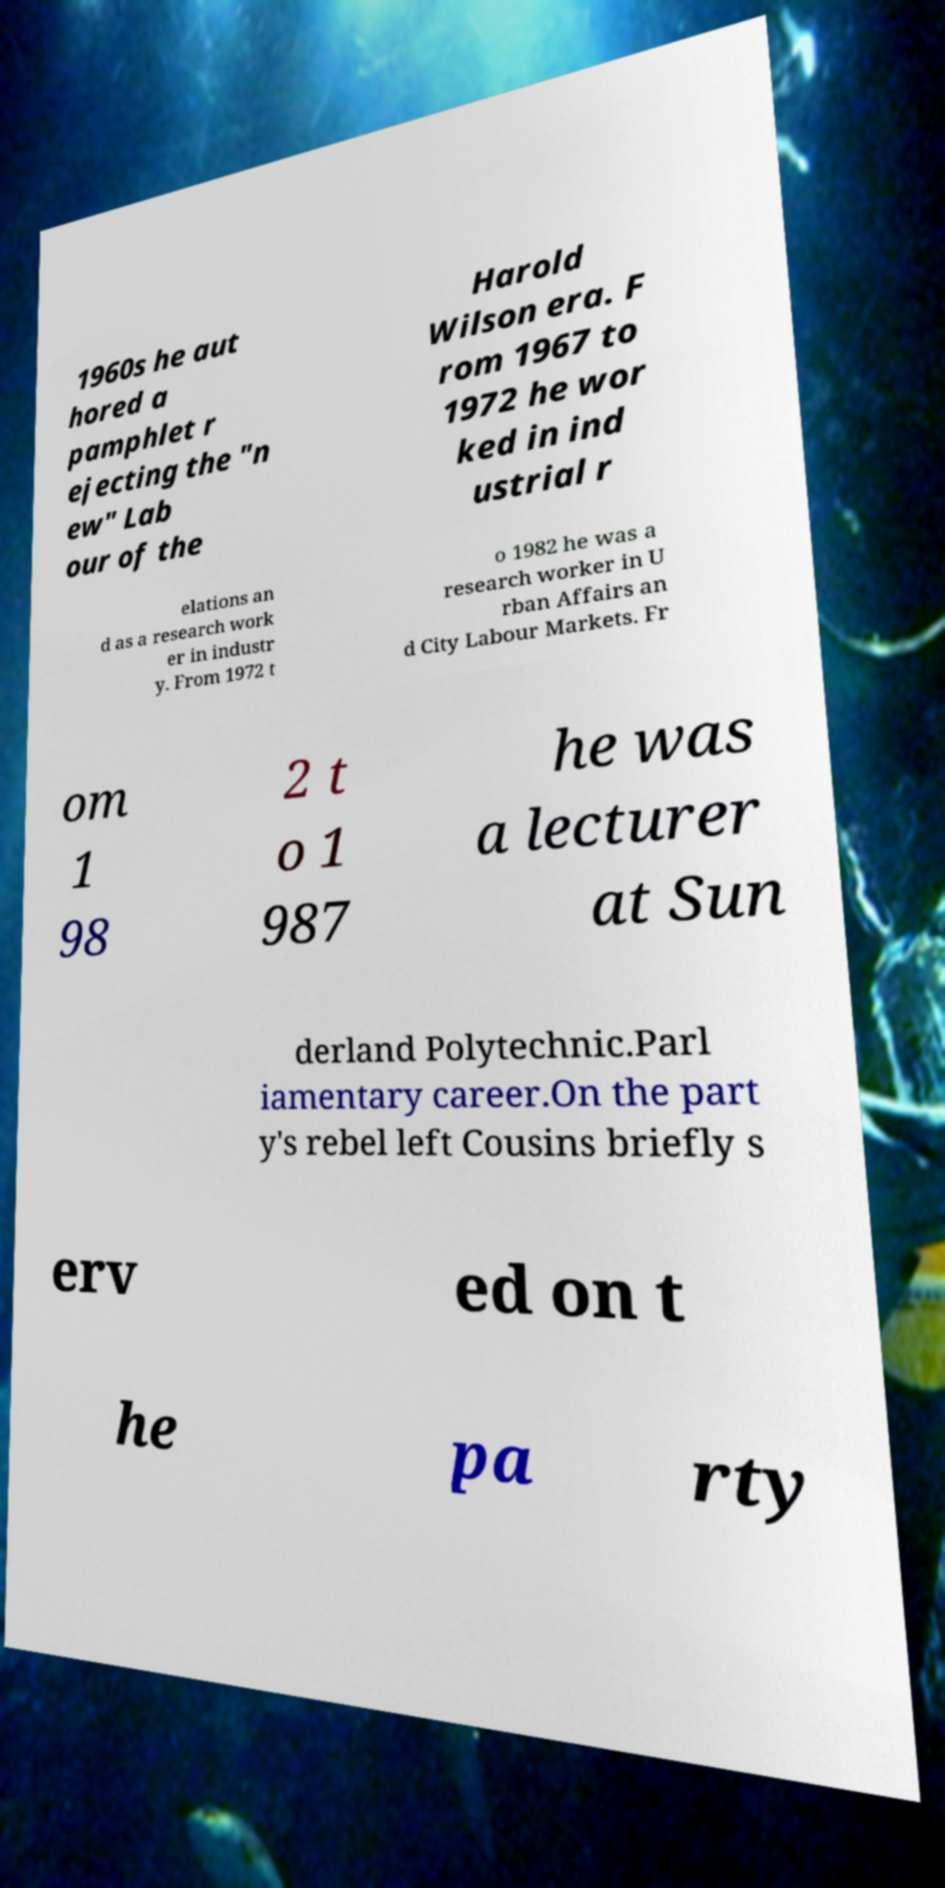For documentation purposes, I need the text within this image transcribed. Could you provide that? 1960s he aut hored a pamphlet r ejecting the "n ew" Lab our of the Harold Wilson era. F rom 1967 to 1972 he wor ked in ind ustrial r elations an d as a research work er in industr y. From 1972 t o 1982 he was a research worker in U rban Affairs an d City Labour Markets. Fr om 1 98 2 t o 1 987 he was a lecturer at Sun derland Polytechnic.Parl iamentary career.On the part y's rebel left Cousins briefly s erv ed on t he pa rty 